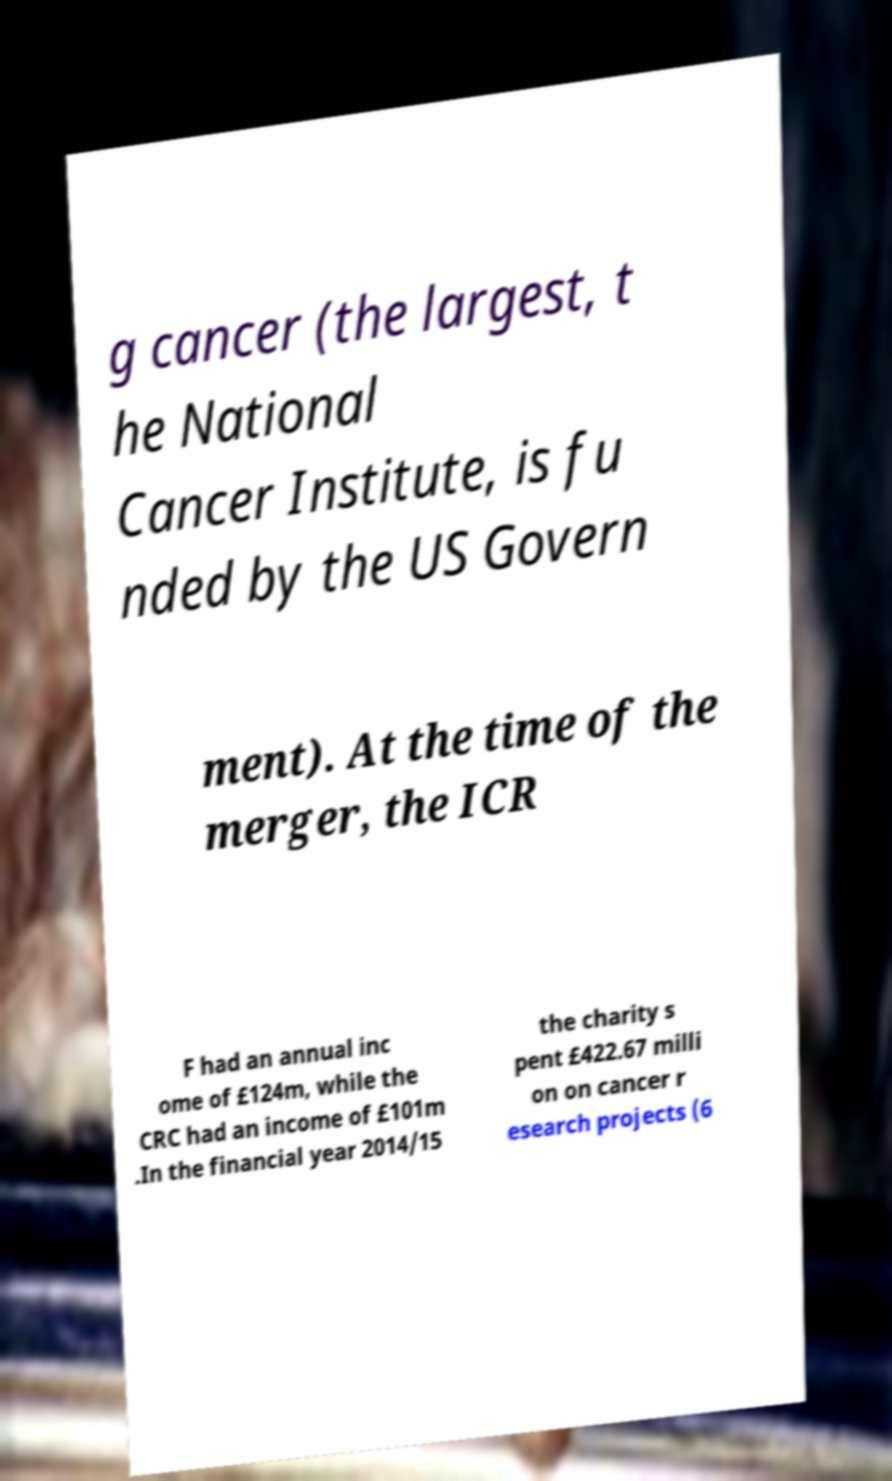Please identify and transcribe the text found in this image. g cancer (the largest, t he National Cancer Institute, is fu nded by the US Govern ment). At the time of the merger, the ICR F had an annual inc ome of £124m, while the CRC had an income of £101m .In the financial year 2014/15 the charity s pent £422.67 milli on on cancer r esearch projects (6 